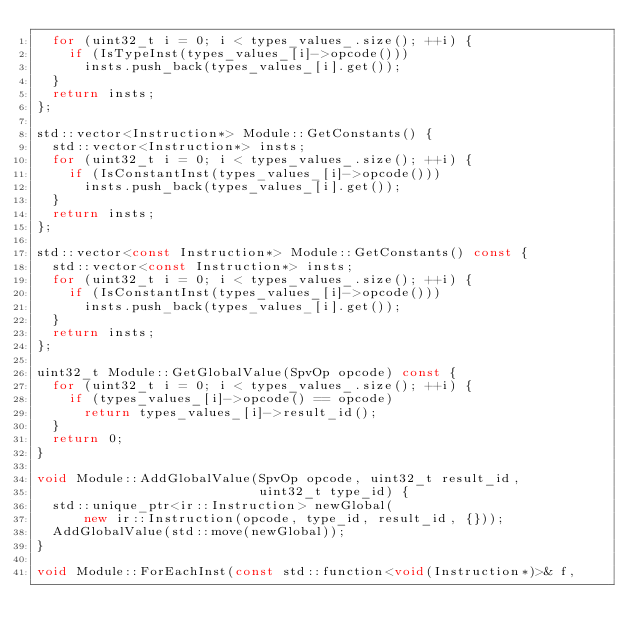<code> <loc_0><loc_0><loc_500><loc_500><_C++_>  for (uint32_t i = 0; i < types_values_.size(); ++i) {
    if (IsTypeInst(types_values_[i]->opcode()))
      insts.push_back(types_values_[i].get());
  }
  return insts;
};

std::vector<Instruction*> Module::GetConstants() {
  std::vector<Instruction*> insts;
  for (uint32_t i = 0; i < types_values_.size(); ++i) {
    if (IsConstantInst(types_values_[i]->opcode()))
      insts.push_back(types_values_[i].get());
  }
  return insts;
};

std::vector<const Instruction*> Module::GetConstants() const {
  std::vector<const Instruction*> insts;
  for (uint32_t i = 0; i < types_values_.size(); ++i) {
    if (IsConstantInst(types_values_[i]->opcode()))
      insts.push_back(types_values_[i].get());
  }
  return insts;
};

uint32_t Module::GetGlobalValue(SpvOp opcode) const {
  for (uint32_t i = 0; i < types_values_.size(); ++i) {
    if (types_values_[i]->opcode() == opcode)
      return types_values_[i]->result_id();
  }
  return 0;
}

void Module::AddGlobalValue(SpvOp opcode, uint32_t result_id,
                            uint32_t type_id) {
  std::unique_ptr<ir::Instruction> newGlobal(
      new ir::Instruction(opcode, type_id, result_id, {}));
  AddGlobalValue(std::move(newGlobal));
}

void Module::ForEachInst(const std::function<void(Instruction*)>& f,</code> 